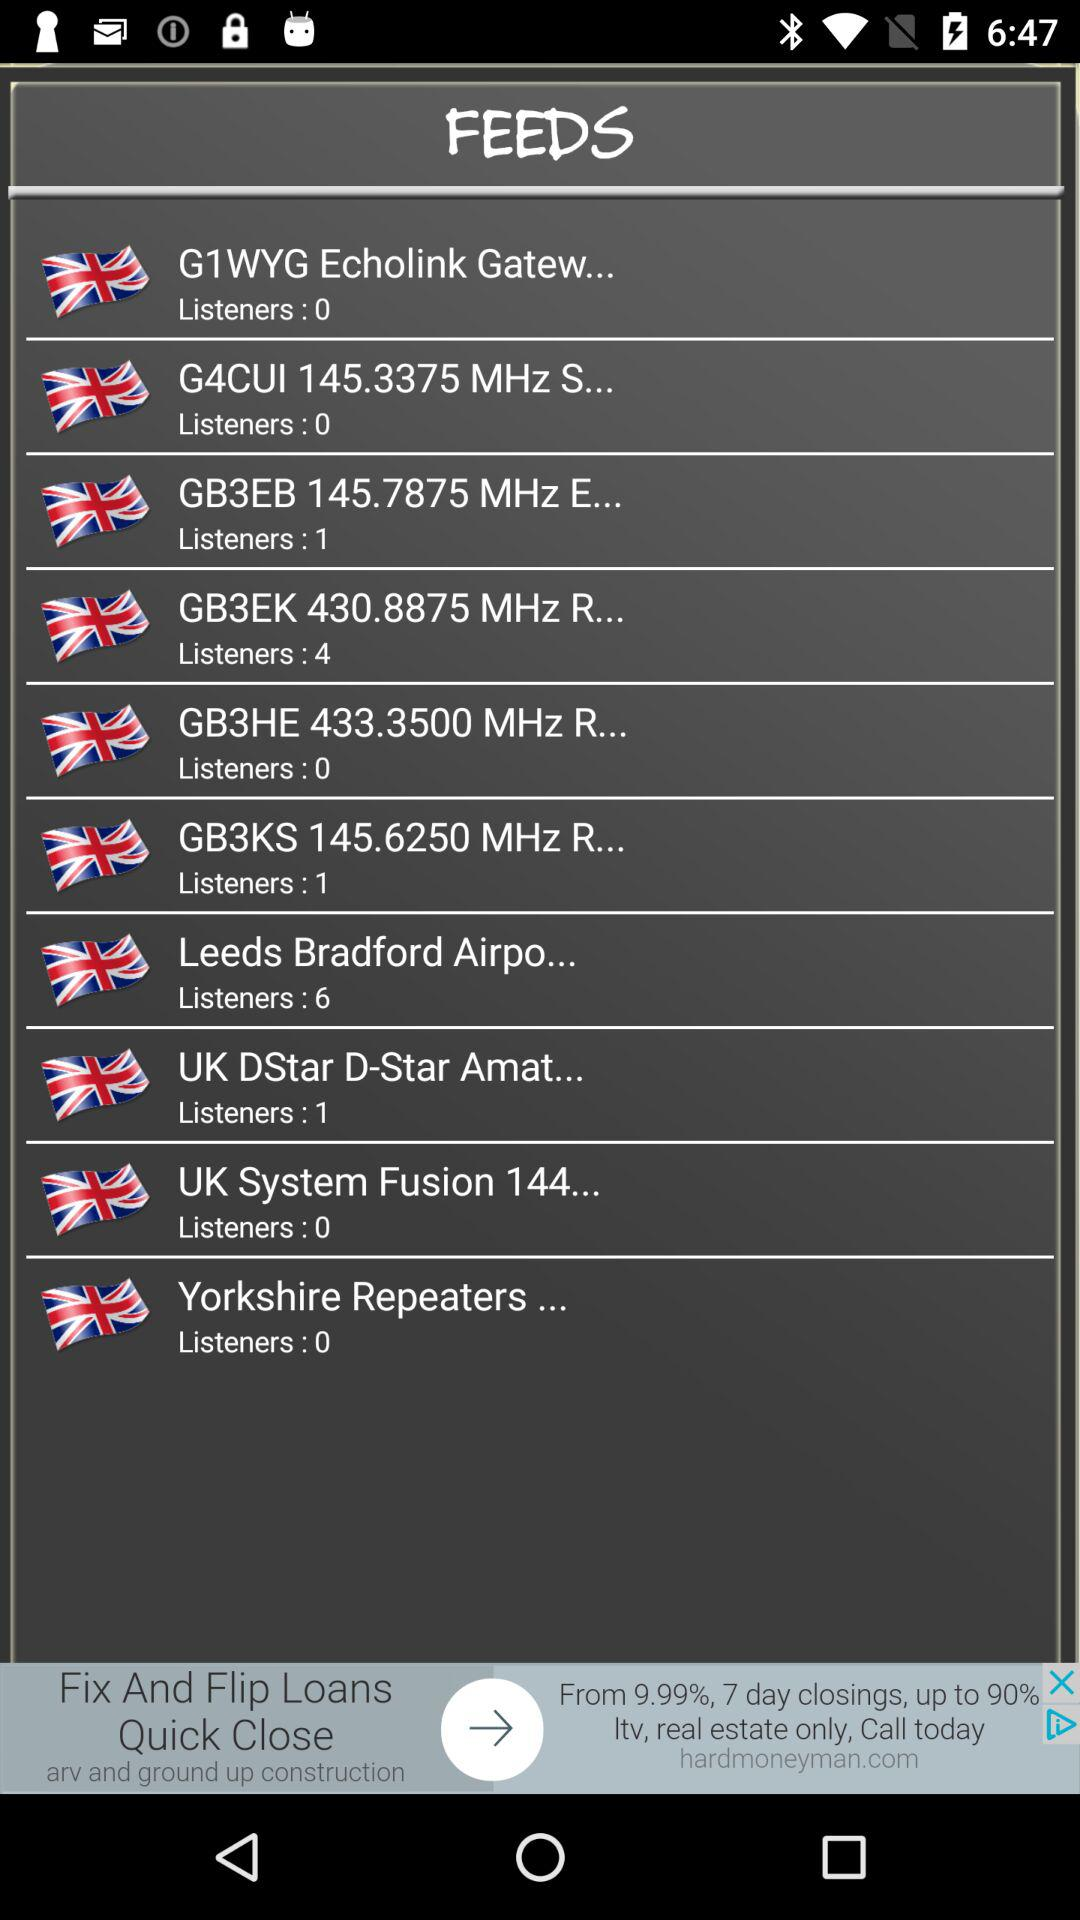How many listeners are there for "UK System Fusion 144..."? There are 0 listeners. 